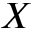<formula> <loc_0><loc_0><loc_500><loc_500>X</formula> 